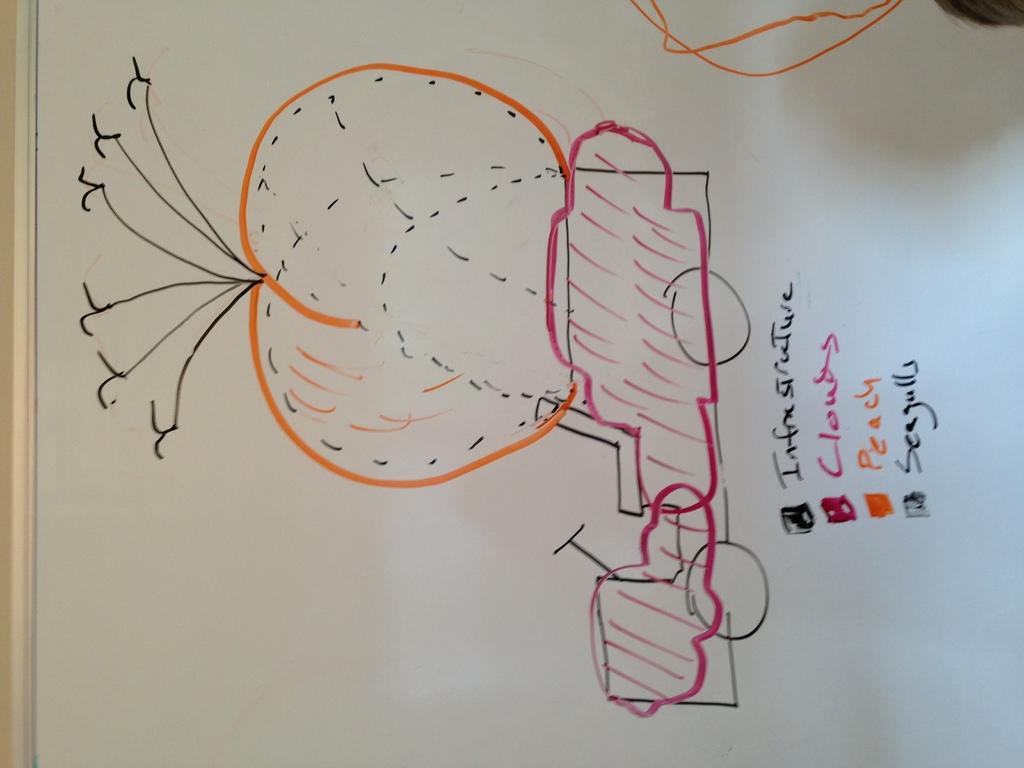What colour does orange represent?
Your response must be concise. Peach. What is the last word in the list?
Ensure brevity in your answer.  Seagulls. 